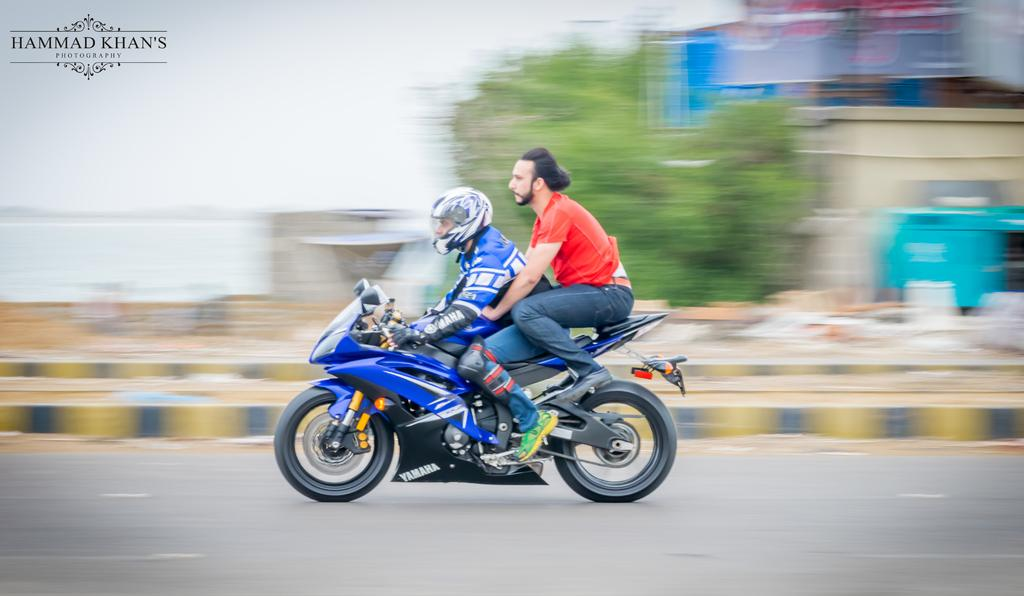What is the man in the image wearing on his head? The man is wearing a helmet in the image. What else is the man wearing? The man is also wearing gloves in the image. What is the man doing in the image? The man is riding a bike in the image. Where is the bike located? The bike is on a road in the image. Who else is present in the image? There is another person in the image, sitting at the back of the man. What can be seen alongside the road? There is a footpath alongside the road in the image. What type of vegetation is visible in the image? Trees are visible in the image. How would you describe the quality of the image? The image is blurred. What type of cracker is the man holding in the image? There is no cracker present in the image; the man is wearing gloves and riding a bike. Where is the top of the image located? The concept of a "top" of the image is not applicable, as the image is two-dimensional and does not have a top or bottom. Can you see a frog in the image? There is no frog present in the image; the image features a man riding a bike with another person on the back, alongside a road with trees and a footpath. 